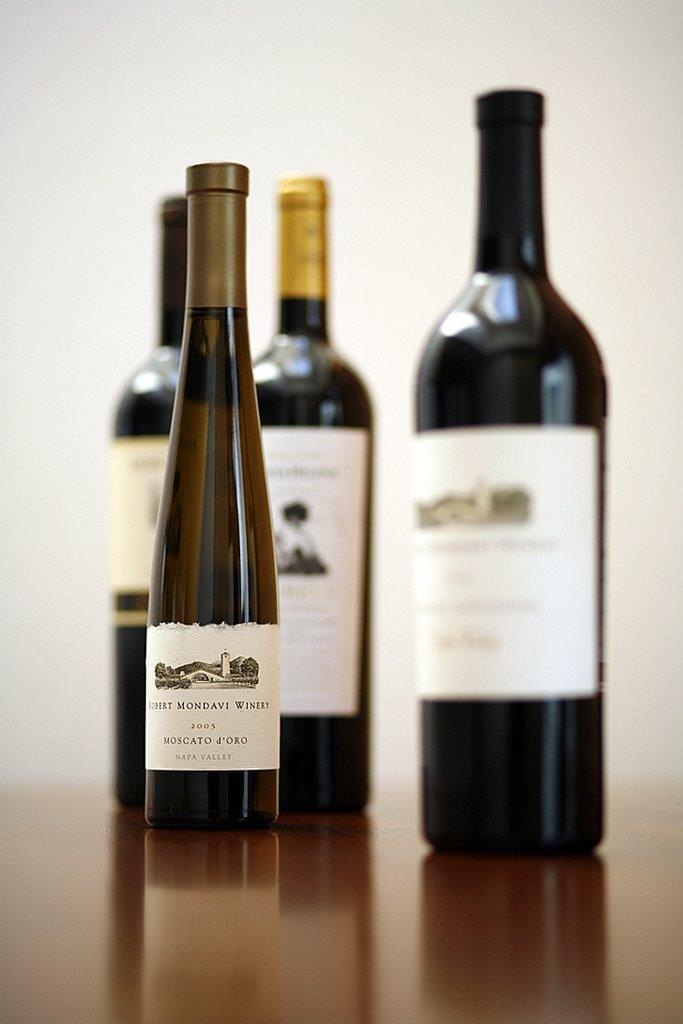Provide a one-sentence caption for the provided image. A small thin 2003 bottle of wine stands in front of other wine bottles. 